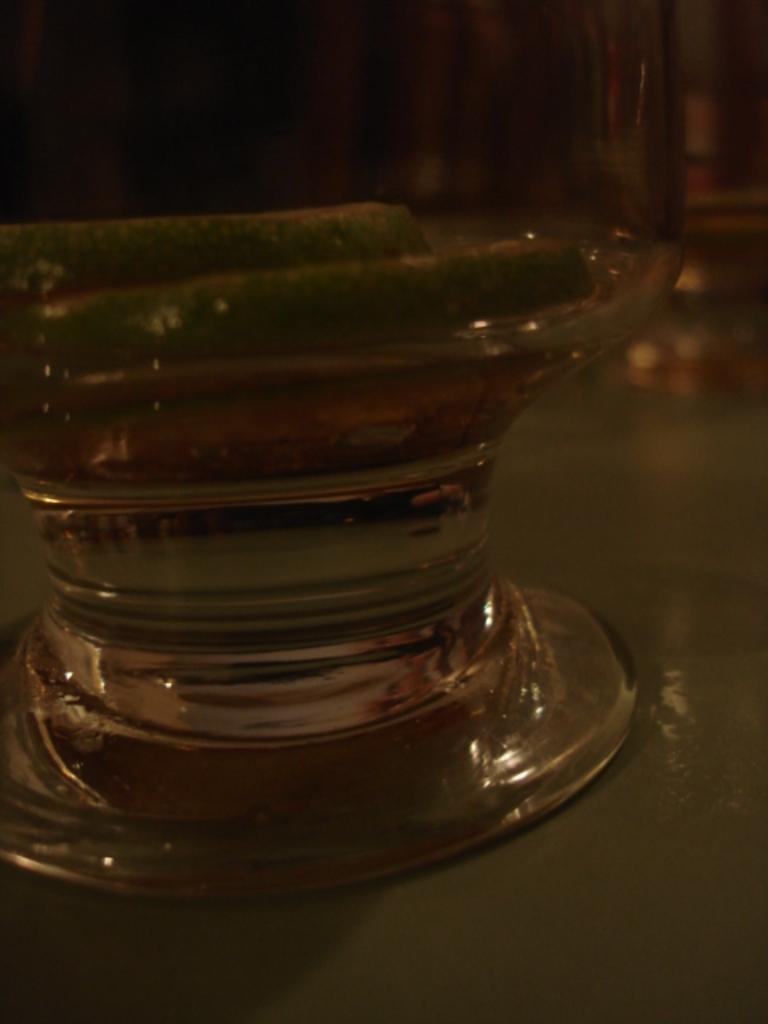What object is visible in the image that is made of glass? There is a glass jar in the image. What is contained within the glass jar? There is something inside the glass jar. Where is the glass jar located in the image? The glass jar is placed on a table. What is the smell of the toes in the image? There are no toes present in the image, so it is not possible to determine their smell. 